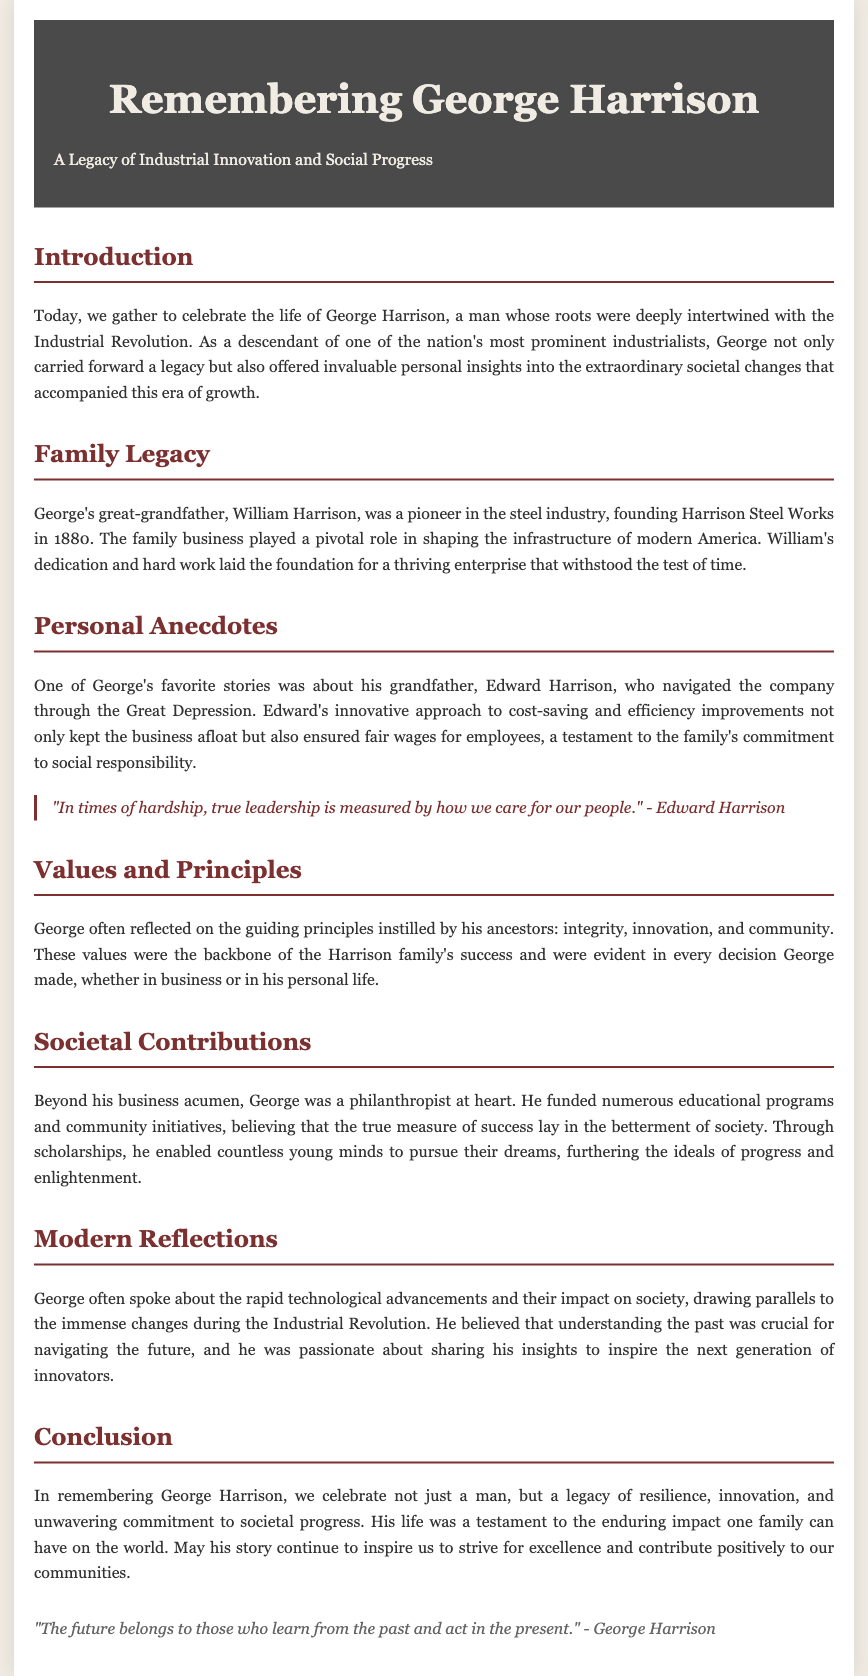What year was Harrison Steel Works founded? The document states that Harrison Steel Works was founded in 1880.
Answer: 1880 Who was George's grandfather? The document mentions that George's grandfather was Edward Harrison.
Answer: Edward Harrison What was Edward Harrison's approach during the Great Depression? The document highlights that Edward's innovative approach involved cost-saving and efficiency improvements.
Answer: Cost-saving and efficiency improvements What values were instilled by George's ancestors? The document lists integrity, innovation, and community as the guiding principles instilled by George's ancestors.
Answer: Integrity, innovation, and community What type of programs did George fund? The document indicates that George funded numerous educational programs and community initiatives.
Answer: Educational programs and community initiatives According to George, what is the true measure of success? The document states that George believed the true measure of success lay in the betterment of society.
Answer: The betterment of society What lesson did George emphasize about understanding the past? The document mentions that George believed understanding the past was crucial for navigating the future.
Answer: Understanding the past What does the closing quote in the document emphasize? The closing quote by George Harrison emphasizes the importance of learning from the past and acting in the present.
Answer: Learning from the past and acting in the present 